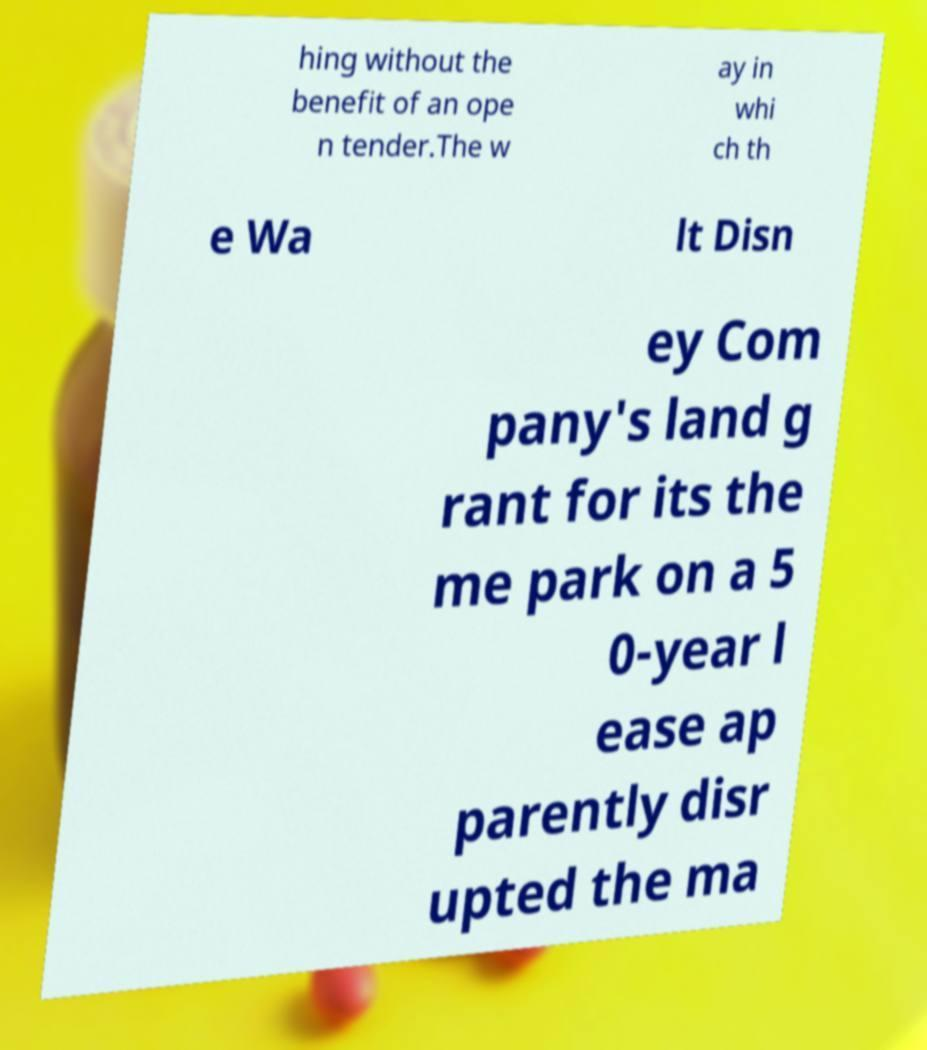Can you accurately transcribe the text from the provided image for me? hing without the benefit of an ope n tender.The w ay in whi ch th e Wa lt Disn ey Com pany's land g rant for its the me park on a 5 0-year l ease ap parently disr upted the ma 